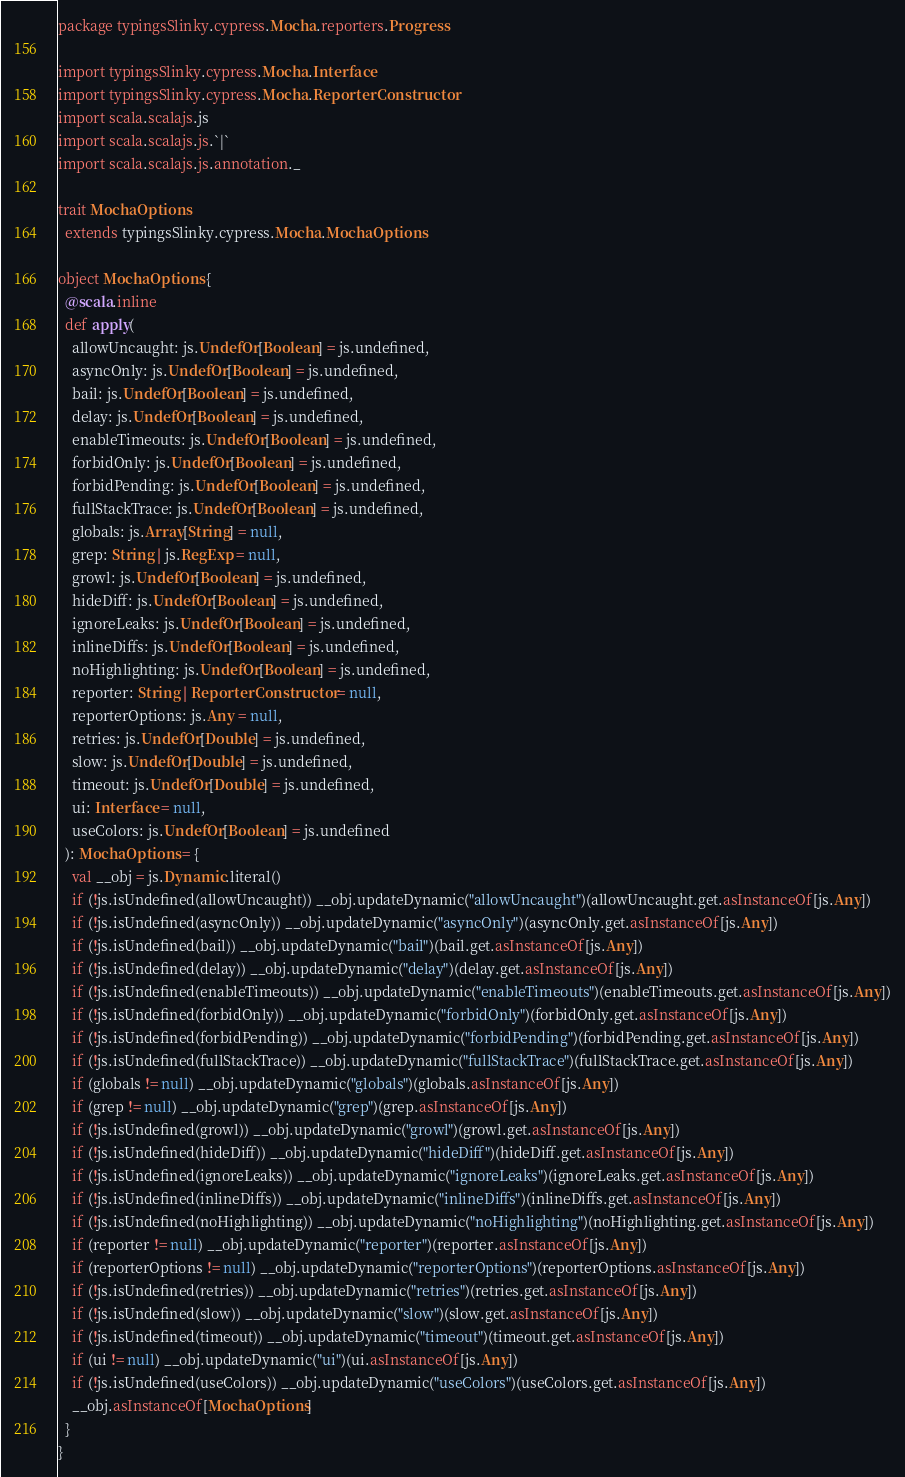<code> <loc_0><loc_0><loc_500><loc_500><_Scala_>package typingsSlinky.cypress.Mocha.reporters.Progress

import typingsSlinky.cypress.Mocha.Interface
import typingsSlinky.cypress.Mocha.ReporterConstructor
import scala.scalajs.js
import scala.scalajs.js.`|`
import scala.scalajs.js.annotation._

trait MochaOptions
  extends typingsSlinky.cypress.Mocha.MochaOptions

object MochaOptions {
  @scala.inline
  def apply(
    allowUncaught: js.UndefOr[Boolean] = js.undefined,
    asyncOnly: js.UndefOr[Boolean] = js.undefined,
    bail: js.UndefOr[Boolean] = js.undefined,
    delay: js.UndefOr[Boolean] = js.undefined,
    enableTimeouts: js.UndefOr[Boolean] = js.undefined,
    forbidOnly: js.UndefOr[Boolean] = js.undefined,
    forbidPending: js.UndefOr[Boolean] = js.undefined,
    fullStackTrace: js.UndefOr[Boolean] = js.undefined,
    globals: js.Array[String] = null,
    grep: String | js.RegExp = null,
    growl: js.UndefOr[Boolean] = js.undefined,
    hideDiff: js.UndefOr[Boolean] = js.undefined,
    ignoreLeaks: js.UndefOr[Boolean] = js.undefined,
    inlineDiffs: js.UndefOr[Boolean] = js.undefined,
    noHighlighting: js.UndefOr[Boolean] = js.undefined,
    reporter: String | ReporterConstructor = null,
    reporterOptions: js.Any = null,
    retries: js.UndefOr[Double] = js.undefined,
    slow: js.UndefOr[Double] = js.undefined,
    timeout: js.UndefOr[Double] = js.undefined,
    ui: Interface = null,
    useColors: js.UndefOr[Boolean] = js.undefined
  ): MochaOptions = {
    val __obj = js.Dynamic.literal()
    if (!js.isUndefined(allowUncaught)) __obj.updateDynamic("allowUncaught")(allowUncaught.get.asInstanceOf[js.Any])
    if (!js.isUndefined(asyncOnly)) __obj.updateDynamic("asyncOnly")(asyncOnly.get.asInstanceOf[js.Any])
    if (!js.isUndefined(bail)) __obj.updateDynamic("bail")(bail.get.asInstanceOf[js.Any])
    if (!js.isUndefined(delay)) __obj.updateDynamic("delay")(delay.get.asInstanceOf[js.Any])
    if (!js.isUndefined(enableTimeouts)) __obj.updateDynamic("enableTimeouts")(enableTimeouts.get.asInstanceOf[js.Any])
    if (!js.isUndefined(forbidOnly)) __obj.updateDynamic("forbidOnly")(forbidOnly.get.asInstanceOf[js.Any])
    if (!js.isUndefined(forbidPending)) __obj.updateDynamic("forbidPending")(forbidPending.get.asInstanceOf[js.Any])
    if (!js.isUndefined(fullStackTrace)) __obj.updateDynamic("fullStackTrace")(fullStackTrace.get.asInstanceOf[js.Any])
    if (globals != null) __obj.updateDynamic("globals")(globals.asInstanceOf[js.Any])
    if (grep != null) __obj.updateDynamic("grep")(grep.asInstanceOf[js.Any])
    if (!js.isUndefined(growl)) __obj.updateDynamic("growl")(growl.get.asInstanceOf[js.Any])
    if (!js.isUndefined(hideDiff)) __obj.updateDynamic("hideDiff")(hideDiff.get.asInstanceOf[js.Any])
    if (!js.isUndefined(ignoreLeaks)) __obj.updateDynamic("ignoreLeaks")(ignoreLeaks.get.asInstanceOf[js.Any])
    if (!js.isUndefined(inlineDiffs)) __obj.updateDynamic("inlineDiffs")(inlineDiffs.get.asInstanceOf[js.Any])
    if (!js.isUndefined(noHighlighting)) __obj.updateDynamic("noHighlighting")(noHighlighting.get.asInstanceOf[js.Any])
    if (reporter != null) __obj.updateDynamic("reporter")(reporter.asInstanceOf[js.Any])
    if (reporterOptions != null) __obj.updateDynamic("reporterOptions")(reporterOptions.asInstanceOf[js.Any])
    if (!js.isUndefined(retries)) __obj.updateDynamic("retries")(retries.get.asInstanceOf[js.Any])
    if (!js.isUndefined(slow)) __obj.updateDynamic("slow")(slow.get.asInstanceOf[js.Any])
    if (!js.isUndefined(timeout)) __obj.updateDynamic("timeout")(timeout.get.asInstanceOf[js.Any])
    if (ui != null) __obj.updateDynamic("ui")(ui.asInstanceOf[js.Any])
    if (!js.isUndefined(useColors)) __obj.updateDynamic("useColors")(useColors.get.asInstanceOf[js.Any])
    __obj.asInstanceOf[MochaOptions]
  }
}

</code> 